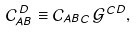Convert formula to latex. <formula><loc_0><loc_0><loc_500><loc_500>\mathcal { C } _ { A B } ^ { \, D } \equiv \mathcal { C } _ { A B C } \, \mathcal { G } ^ { C D } ,</formula> 